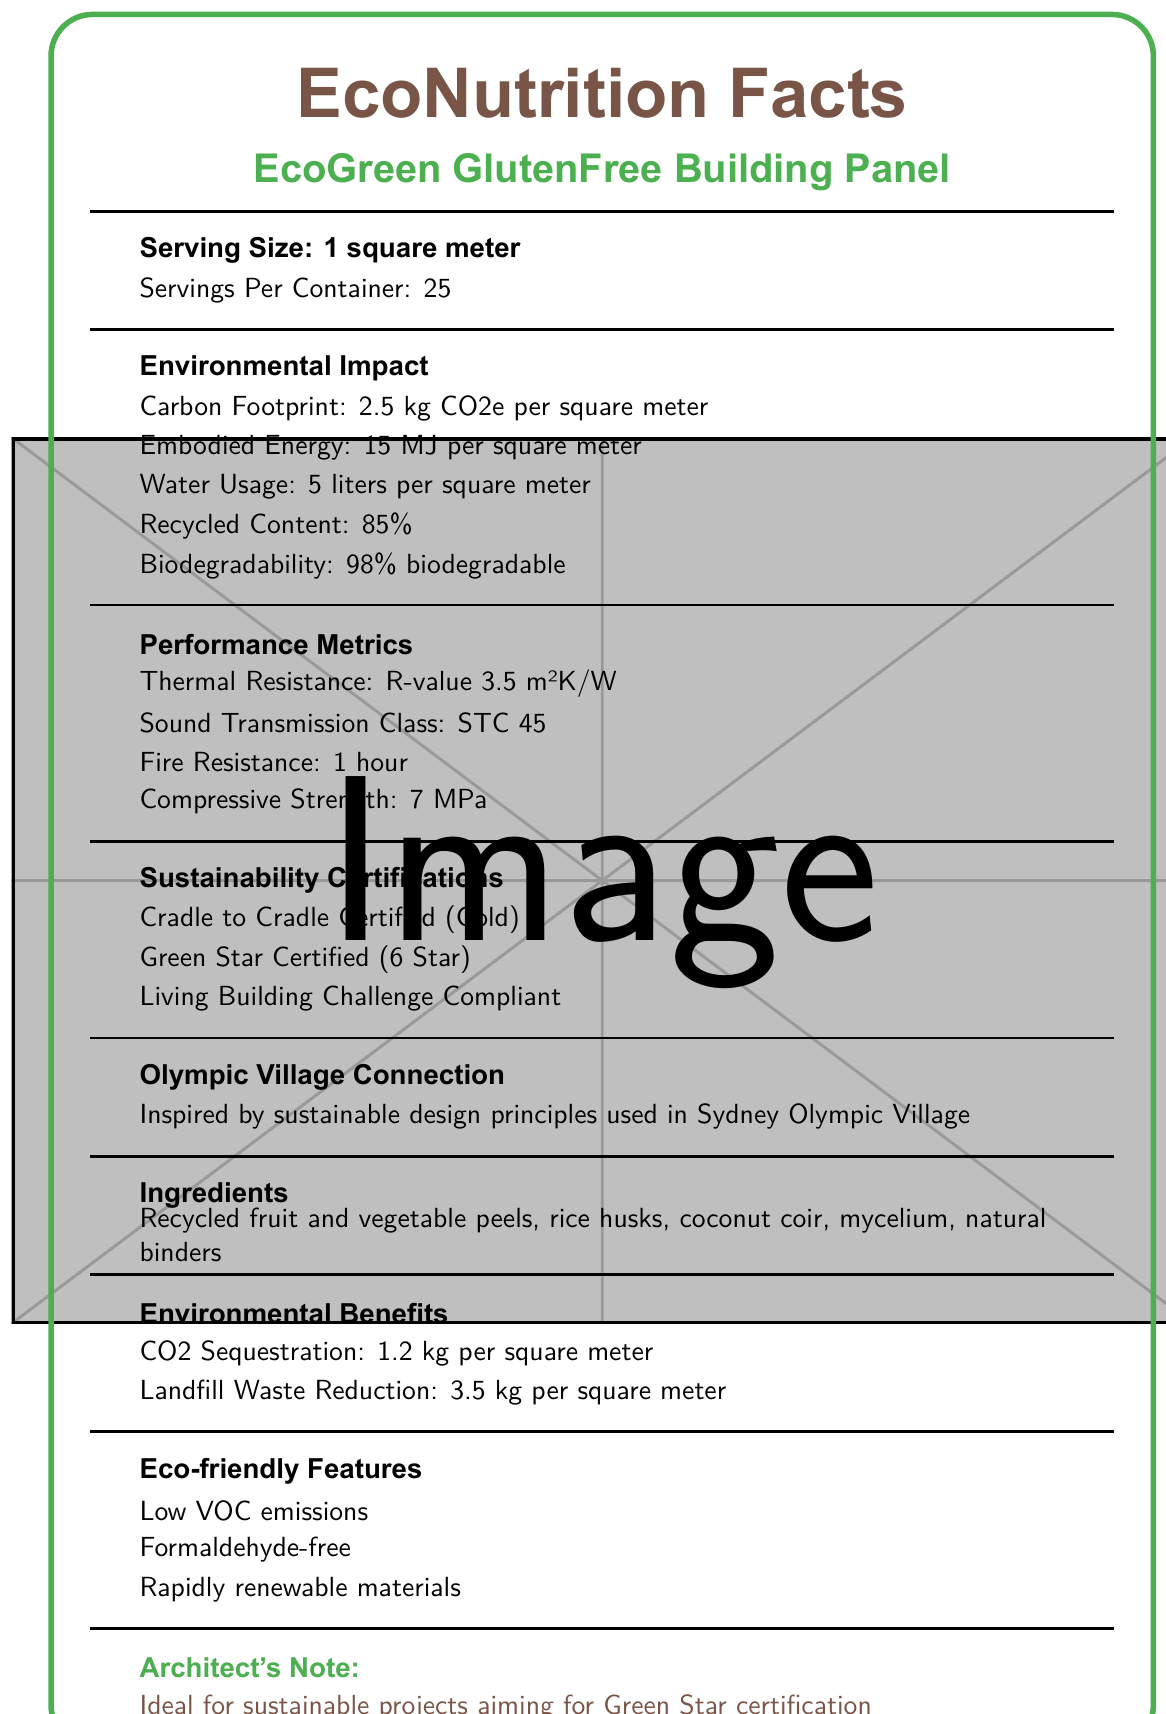what is the serving size? The serving size is explicitly stated as "1 square meter."
Answer: 1 square meter how many servings are there per container? The document states "Servings Per Container: 25."
Answer: 25 which ingredient in the EcoGreen GlutenFree Building Panel originates from fungi? The ingredients list includes mycelium, which is a substance derived from fungi.
Answer: mycelium what certifications does the building panel have? The document lists these three sustainability certifications under “Sustainability Certifications.”
Answer: Cradle to Cradle Certified (Gold), Green Star Certified (6 Star), Living Building Challenge Compliant what is the thermal resistance of the building panel? The document specifies "Thermal Resistance: R-value 3.5 m²K/W" under "Performance Metrics."
Answer: R-value 3.5 m²K/W what is the carbon footprint of using one square meter of this material? The carbon footprint is listed as "2.5 kg CO2e per square meter" under "Environmental Impact."
Answer: 2.5 kg CO2e how much embodied energy is there per square meter of this building material? The document specifies "Embodied Energy: 15 MJ per square meter" under "Environmental Impact."
Answer: 15 MJ What is the percentage of recycled content in the building panel? The recycled content is listed as "85%" under "Environmental Impact."
Answer: 85% what is the water usage per square meter for this building material? The document states "Water Usage: 5 liters per square meter" under "Environmental Impact."
Answer: 5 liters What is the sound transmission class (STC) rating of the building panel? According to the document, the Sound Transmission Class is "STC 45" under "Performance Metrics."
Answer: STC 45 what is the fire resistance rating of the panel? The fire resistance is specified as "1 hour" under "Performance Metrics."
Answer: 1 hour what are the main ingredients used in this building panel? These ingredients are listed under "Ingredients."
Answer: Recycled fruit and vegetable peels, rice husks, coconut coir, mycelium, natural binders which of the following is an EcoGreen GlutenFree Building Panel feature? A. High formaldehyde emissions B. Low VOC emissions C. Non-renewable materials D. Contains asbestos The document states that the panel has "Low VOC emissions" and is "Formaldehyde-free," while options A, C, and D are not mentioned or contradicted.
Answer: B What inspired the design principles of the EcoGreen GlutenFree Building Panel? A. Traditional construction methods B. Sustainable urban transit C. Sydney Olympic Village D. Historical architecture The document mentions that the panel was "Inspired by sustainable design principles used in Sydney Olympic Village."
Answer: C is the EcoGreen GlutenFree Building Panel biodegradable? The document states that it is "98% biodegradable."
Answer: Yes what is the main idea of the document? The document provides comprehensive details about the building panel's specifications, environmental impacts, performance metrics, certifications, and special notes about its sustainable characteristics and inspiration from the Sydney Olympic Village.
Answer: The EcoGreen GlutenFree Building Panel is a sustainable, high-performance building material made from recycled food waste, featuring significant environmental and performance benefits, numerous sustainability certifications, and eco-friendly features. where can I purchase EcoGreen GlutenFree Building Panel? The document includes product specifications but does not provide purchasing details.
Answer: Not enough information 